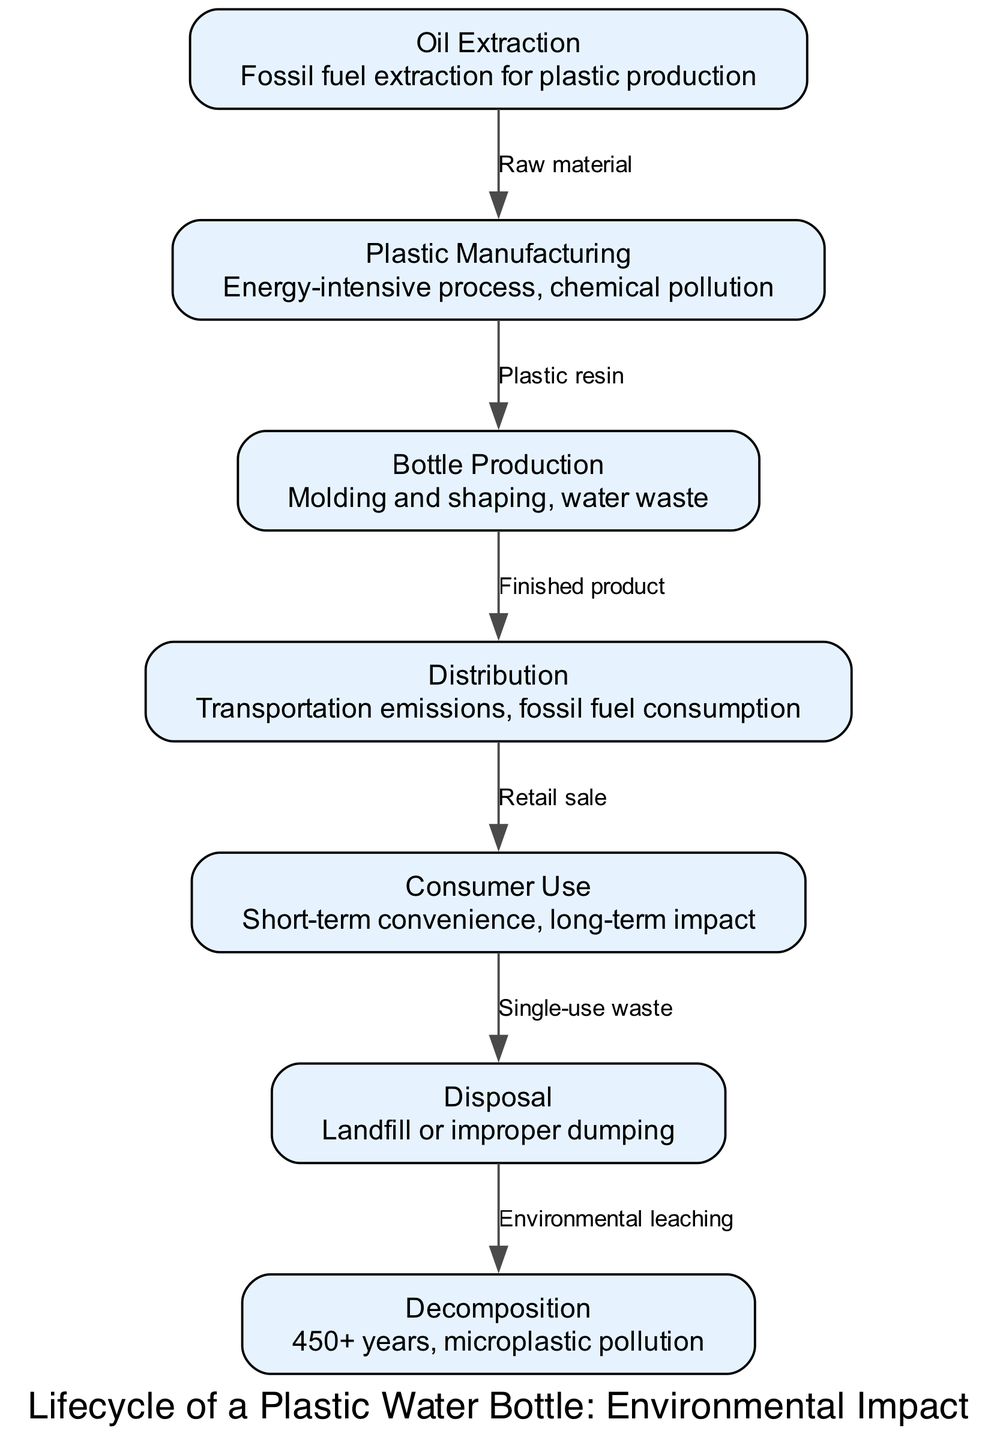What is the first stage of the lifecycle? The diagram starts with the node labeled "Oil Extraction," which is the initial stage in the process of producing a plastic water bottle.
Answer: Oil Extraction How many nodes are present in the diagram? By counting the listed nodes, there are seven distinct stages displayed in the lifecycle of a plastic water bottle.
Answer: 7 What is the environmental impact of "Plastic Manufacturing"? The description for this node indicates that it is an "Energy-intensive process, chemical pollution," highlighting its significant environmental consequences.
Answer: Energy-intensive process, chemical pollution Which stage is directly associated with "Consumer Use"? The diagram shows that "Consumer Use" is directly followed by the "Disposal" stage, indicating that the consumer's use leads to the waste management side of the bottle's lifecycle.
Answer: Disposal What raw material is used in the lifecycle according to the diagram? The diagram specifies that the raw material for plastic production comes from "Oil Extraction," linking fossil fuel extraction to the production of plastic.
Answer: Oil Extraction What is the last stage of the lifecycle? The final node in the diagram is "Decomposition," which describes the process by which plastic bottles break down, emphasizing the timeline extending to over 450 years and the resulting microplastic pollution.
Answer: Decomposition What transition occurs from the "Distribution" stage? The edge label from "Distribution" to "Consumer Use" indicates that the transition represents the "Retail sale," clarifying that products are passed on to consumers at this stage.
Answer: Retail sale How long does it take for plastic to decompose after disposal? The "Decomposition" node states that it takes "450+ years," indicating the extensive time required for plastic waste to naturally break down.
Answer: 450+ years 